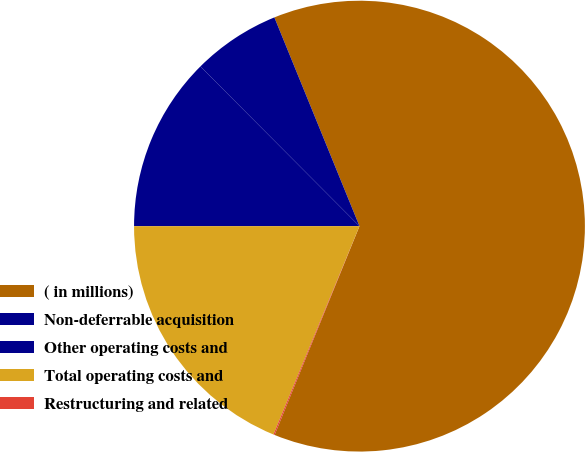<chart> <loc_0><loc_0><loc_500><loc_500><pie_chart><fcel>( in millions)<fcel>Non-deferrable acquisition<fcel>Other operating costs and<fcel>Total operating costs and<fcel>Restructuring and related<nl><fcel>62.3%<fcel>6.31%<fcel>12.53%<fcel>18.76%<fcel>0.09%<nl></chart> 